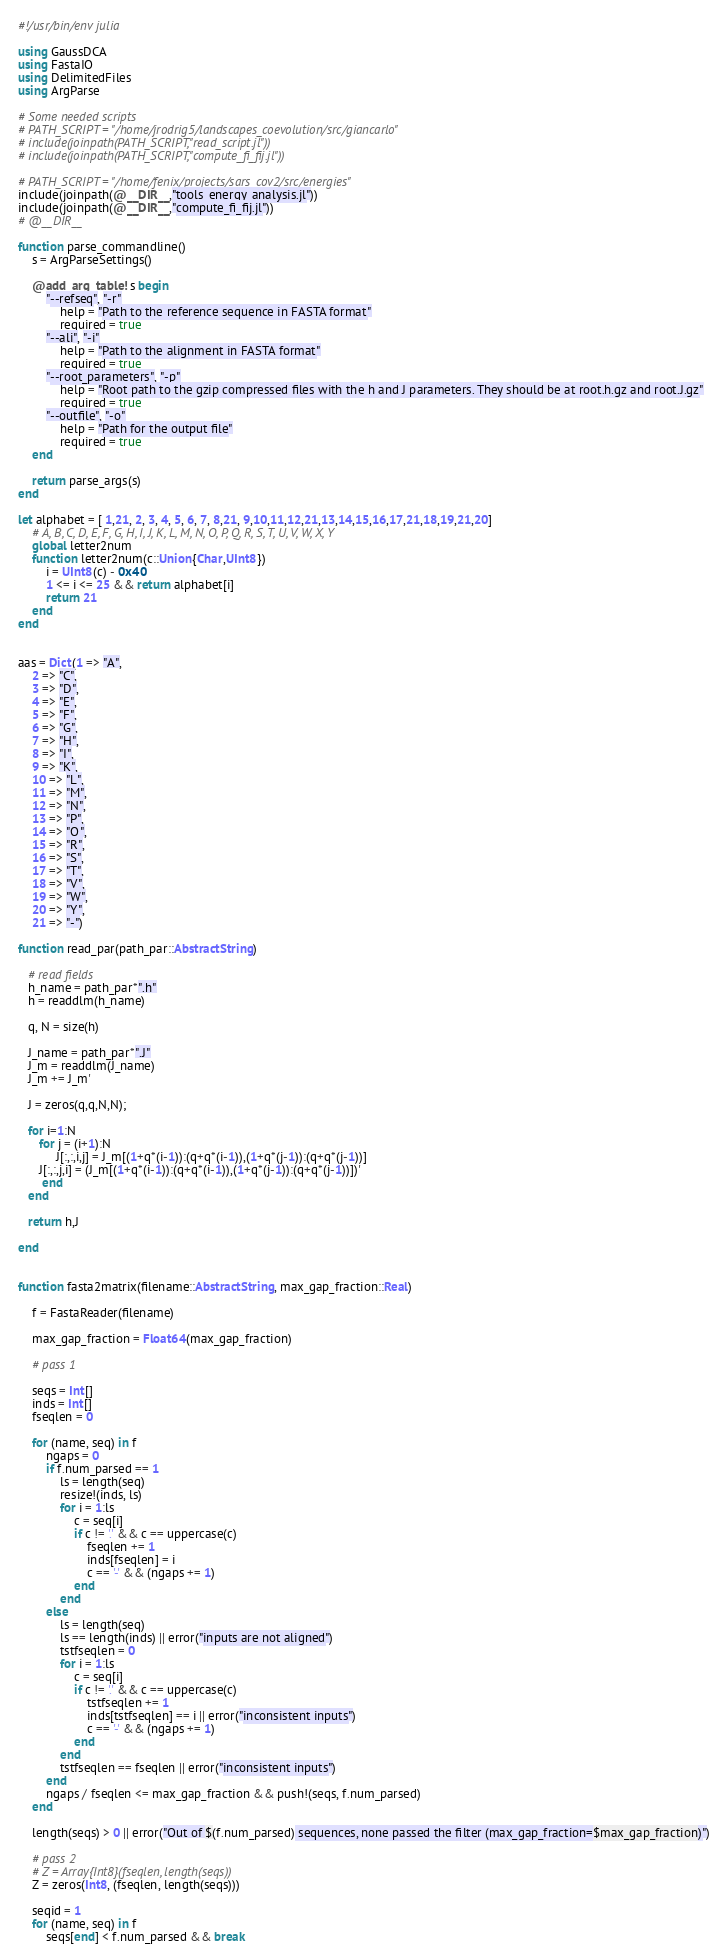<code> <loc_0><loc_0><loc_500><loc_500><_Julia_>#!/usr/bin/env julia

using GaussDCA
using FastaIO
using DelimitedFiles
using ArgParse

# Some needed scripts
# PATH_SCRIPT = "/home/jrodrig5/landscapes_coevolution/src/giancarlo"
# include(joinpath(PATH_SCRIPT,"read_script.jl"))
# include(joinpath(PATH_SCRIPT,"compute_fi_fij.jl"))

# PATH_SCRIPT = "/home/fenix/projects/sars_cov2/src/energies"
include(joinpath(@__DIR__,"tools_energy_analysis.jl"))
include(joinpath(@__DIR__,"compute_fi_fij.jl"))
# @__DIR__

function parse_commandline()
    s = ArgParseSettings()

    @add_arg_table! s begin
        "--refseq", "-r"
            help = "Path to the reference sequence in FASTA format"
            required = true
        "--ali", "-i"
            help = "Path to the alignment in FASTA format"
            required = true
        "--root_parameters", "-p"
            help = "Root path to the gzip compressed files with the h and J parameters. They should be at root.h.gz and root.J.gz"
            required = true
        "--outfile", "-o"
            help = "Path for the output file"
            required = true
    end

    return parse_args(s)
end

let alphabet = [ 1,21, 2, 3, 4, 5, 6, 7, 8,21, 9,10,11,12,21,13,14,15,16,17,21,18,19,21,20]
    # A, B, C, D, E, F, G, H, I, J, K, L, M, N, O, P, Q, R, S, T, U, V, W, X, Y
    global letter2num
    function letter2num(c::Union{Char,UInt8})
        i = UInt8(c) - 0x40
        1 <= i <= 25 && return alphabet[i]
        return 21
    end
end


aas = Dict(1 => "A",
    2 => "C",
    3 => "D",
    4 => "E",
    5 => "F",
    6 => "G",
    7 => "H",
    8 => "I",
    9 => "K",
    10 => "L",
    11 => "M",
    12 => "N",
    13 => "P",
    14 => "Q",
    15 => "R",
    16 => "S",
    17 => "T",
    18 => "V",
    19 => "W",
    20 => "Y",
    21 => "-")
    
function read_par(path_par::AbstractString)

   # read fields
   h_name = path_par*".h"
   h = readdlm(h_name)

   q, N = size(h)

   J_name = path_par*".J"
   J_m = readdlm(J_name)
   J_m += J_m'

   J = zeros(q,q,N,N);

   for i=1:N
      for j = (i+1):N
           J[:,:,i,j] = J_m[(1+q*(i-1)):(q+q*(i-1)),(1+q*(j-1)):(q+q*(j-1))]
      J[:,:,j,i] = (J_m[(1+q*(i-1)):(q+q*(i-1)),(1+q*(j-1)):(q+q*(j-1))])'
       end
   end

   return h,J

end


function fasta2matrix(filename::AbstractString, max_gap_fraction::Real)

    f = FastaReader(filename)

    max_gap_fraction = Float64(max_gap_fraction)

    # pass 1

    seqs = Int[]
    inds = Int[]
    fseqlen = 0

    for (name, seq) in f
        ngaps = 0
        if f.num_parsed == 1
            ls = length(seq)
            resize!(inds, ls)
            for i = 1:ls
                c = seq[i]
                if c != '.' && c == uppercase(c)
                    fseqlen += 1
                    inds[fseqlen] = i
                    c == '-' && (ngaps += 1)
                end
            end
        else
            ls = length(seq)
            ls == length(inds) || error("inputs are not aligned")
            tstfseqlen = 0
            for i = 1:ls
                c = seq[i]
                if c != '.' && c == uppercase(c)
                    tstfseqlen += 1
                    inds[tstfseqlen] == i || error("inconsistent inputs")
                    c == '-' && (ngaps += 1)
                end
            end
            tstfseqlen == fseqlen || error("inconsistent inputs")
        end
        ngaps / fseqlen <= max_gap_fraction && push!(seqs, f.num_parsed)
    end

    length(seqs) > 0 || error("Out of $(f.num_parsed) sequences, none passed the filter (max_gap_fraction=$max_gap_fraction)")

    # pass 2
    # Z = Array{Int8}(fseqlen, length(seqs))
    Z = zeros(Int8, (fseqlen, length(seqs)))

    seqid = 1
    for (name, seq) in f
        seqs[end] < f.num_parsed && break</code> 